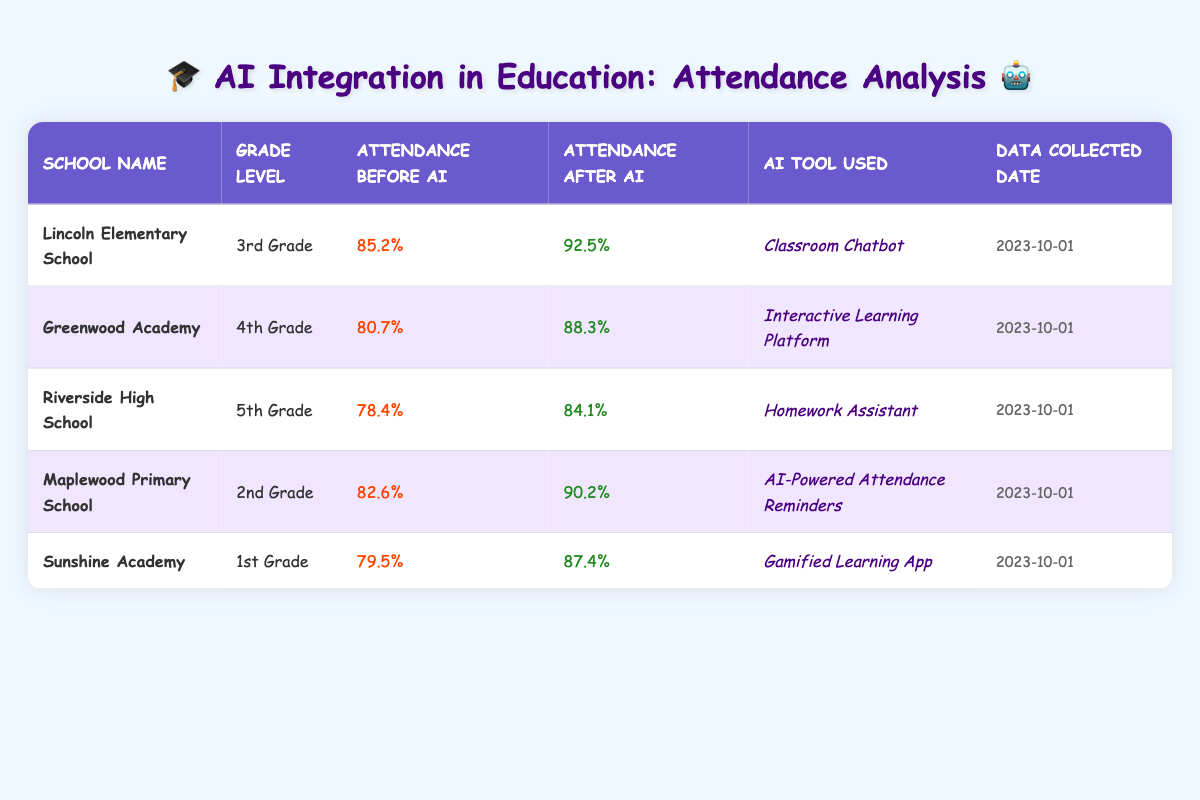What is the attendance rate at Lincoln Elementary School before AI integration? The table shows the attendance rate before AI integration for Lincoln Elementary School listed as 85.2%.
Answer: 85.2% Which AI tool was used at Sunshine Academy? From the table, the AI tool used at Sunshine Academy is identified as the "Gamified Learning App."
Answer: Gamified Learning App What is the percentage increase in attendance from before to after AI integration at Maplewood Primary School? The attendance before AI at Maplewood Primary School is 82.6%, and after AI, it is 90.2%. The increase is calculated as 90.2% - 82.6% = 7.6%.
Answer: 7.6% Did Riverside High School experience an increase or decrease in attendance after AI integration? The table reveals that Riverside High School's attendance changed from 78.4% before AI to 84.1% after AI, indicating an increase in attendance.
Answer: Yes What is the average attendance rate after AI integration across all listed schools? The attendance rates after AI integration for the schools are: 92.5%, 88.3%, 84.1%, 90.2%, and 87.4%. Adding these yields 92.5 + 88.3 + 84.1 + 90.2 + 87.4 = 442.5. Dividing by 5 results in an average of 442.5 / 5 = 88.5%.
Answer: 88.5% Which grade level had the highest attendance rate after AI integration? After checking the attendance rates after AI integration, Lincoln Elementary School with 92.5% in 3rd Grade had the highest percentage compared to the other schools.
Answer: 3rd Grade 